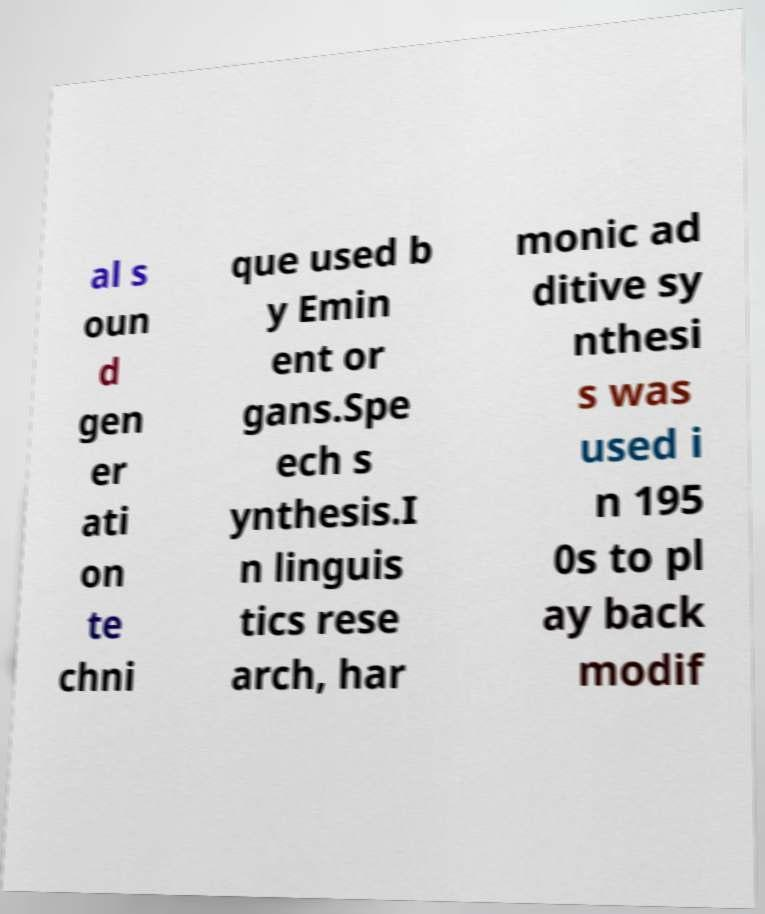For documentation purposes, I need the text within this image transcribed. Could you provide that? al s oun d gen er ati on te chni que used b y Emin ent or gans.Spe ech s ynthesis.I n linguis tics rese arch, har monic ad ditive sy nthesi s was used i n 195 0s to pl ay back modif 